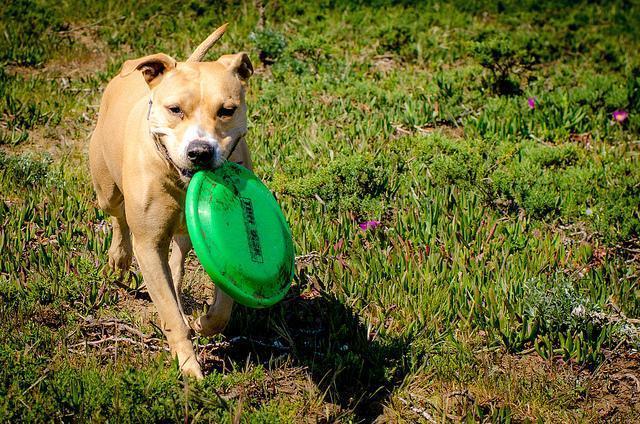How many dogs are in the photo?
Give a very brief answer. 1. How many benches are in a row?
Give a very brief answer. 0. 